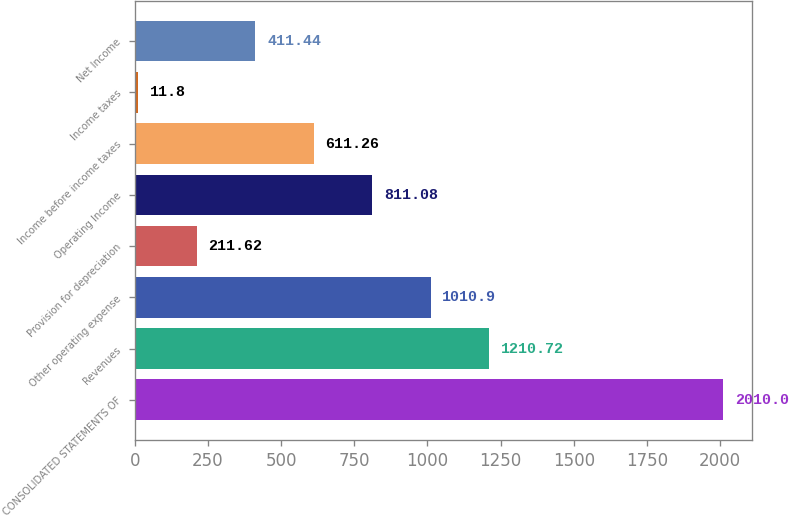Convert chart to OTSL. <chart><loc_0><loc_0><loc_500><loc_500><bar_chart><fcel>CONSOLIDATED STATEMENTS OF<fcel>Revenues<fcel>Other operating expense<fcel>Provision for depreciation<fcel>Operating Income<fcel>Income before income taxes<fcel>Income taxes<fcel>Net Income<nl><fcel>2010<fcel>1210.72<fcel>1010.9<fcel>211.62<fcel>811.08<fcel>611.26<fcel>11.8<fcel>411.44<nl></chart> 